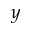Convert formula to latex. <formula><loc_0><loc_0><loc_500><loc_500>y</formula> 